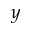Convert formula to latex. <formula><loc_0><loc_0><loc_500><loc_500>y</formula> 